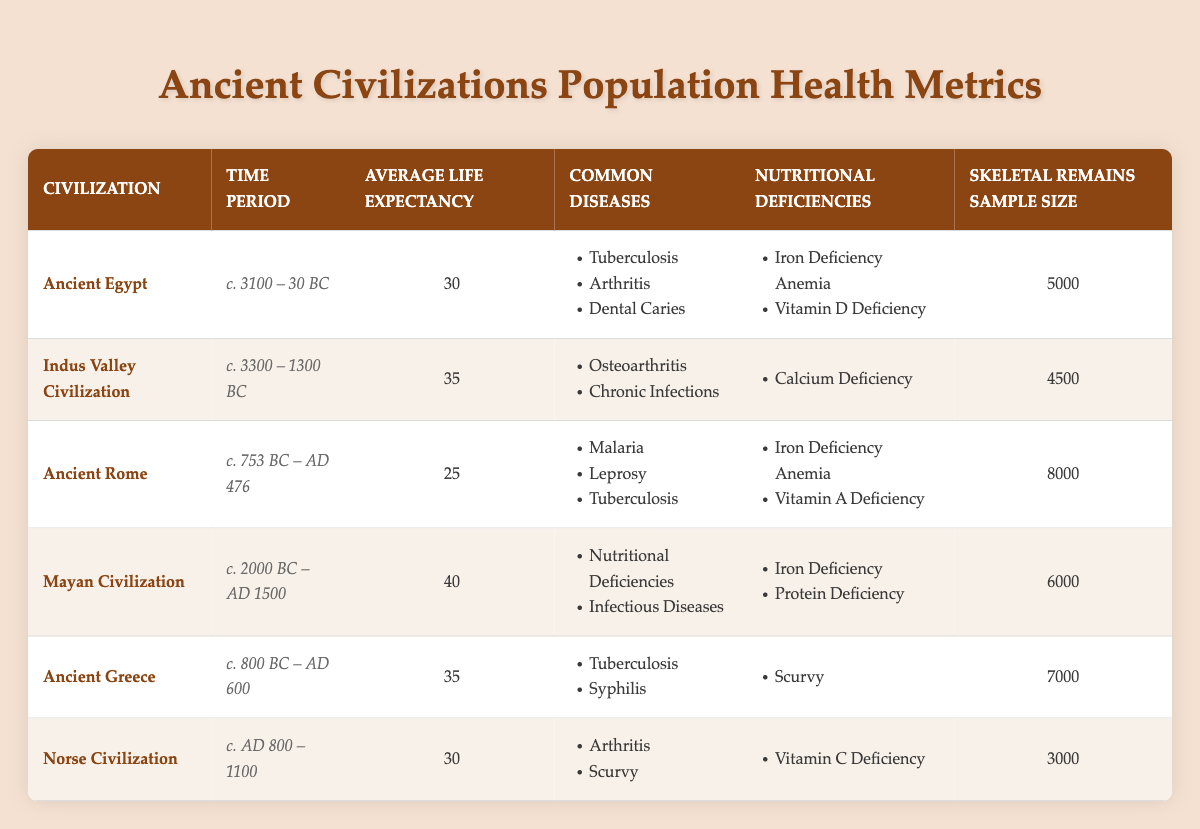What is the average life expectancy of the Mayan Civilization? The life expectancy for the Mayan Civilization, as indicated in the table, is given directly as 40 years.
Answer: 40 Which civilization had the highest number of skeletal remains sampled? By examining the sample sizes listed for each civilization, Ancient Rome has the largest number at 8000 skeletal remains.
Answer: Ancient Rome True or False: Calcium deficiency was a nutritional deficiency in Ancient Greece. The table lists nutritional deficiencies for Ancient Greece and states only "Scurvy." Therefore, calcium deficiency is not mentioned as being present, making the statement false.
Answer: False What is the difference in average life expectancy between the Ancient Egypt and Indus Valley Civilization? The average life expectancy for Ancient Egypt is 30 years and for Indus Valley is 35 years. The difference is calculated as 35 - 30 = 5 years.
Answer: 5 Which common disease was found in both Ancient Rome and Ancient Greece? The table indicates that both Ancient Rome and Ancient Greece had "Tuberculosis" listed as a common disease; therefore, it is the shared disease between them.
Answer: Tuberculosis What is the average life expectancy of civilizations that experienced nutritional deficiencies of iron? The civilizations affected by iron deficiency as per the data are Ancient Egypt, Ancient Rome, and the Mayan Civilization with life expectancies of 30, 25, and 40 years respectively. The average calculation is (30 + 25 + 40) / 3 = 31.67 or approximately 32 years.
Answer: 32 Which civilization had the lowest average life expectancy, and what were its common diseases? The table shows that Ancient Rome had the lowest average life expectancy at 25 years. Its common diseases listed were Malaria, Leprosy, and Tuberculosis.
Answer: Ancient Rome; Malaria, Leprosy, Tuberculosis How many civilizations listed had a skeletal remains sample size of less than 5000? The table shows that the Norse Civilization (3000) and Ancient Egypt (5000) had sample sizes below the 5000 threshold. Thus, only the Norse Civilization has a sample size below 5000.
Answer: 1 What is the most common nutritional deficiency reported among the civilizations listed? Upon reviewing the nutritional deficiencies, "Iron Deficiency" appears in multiple civilizations including Ancient Rome and the Mayan Civilization. It's not the only one but among those listed, "Iron Deficiency" appears most frequently.
Answer: Iron Deficiency List the common diseases for the civilization with the lowest life expectancy, and what is that life expectancy? The civilization with the lowest life expectancy is Ancient Rome with an average of 25 years. The common diseases for this civilization listed are Malaria, Leprosy, and Tuberculosis.
Answer: 25 years; Malaria, Leprosy, Tuberculosis 